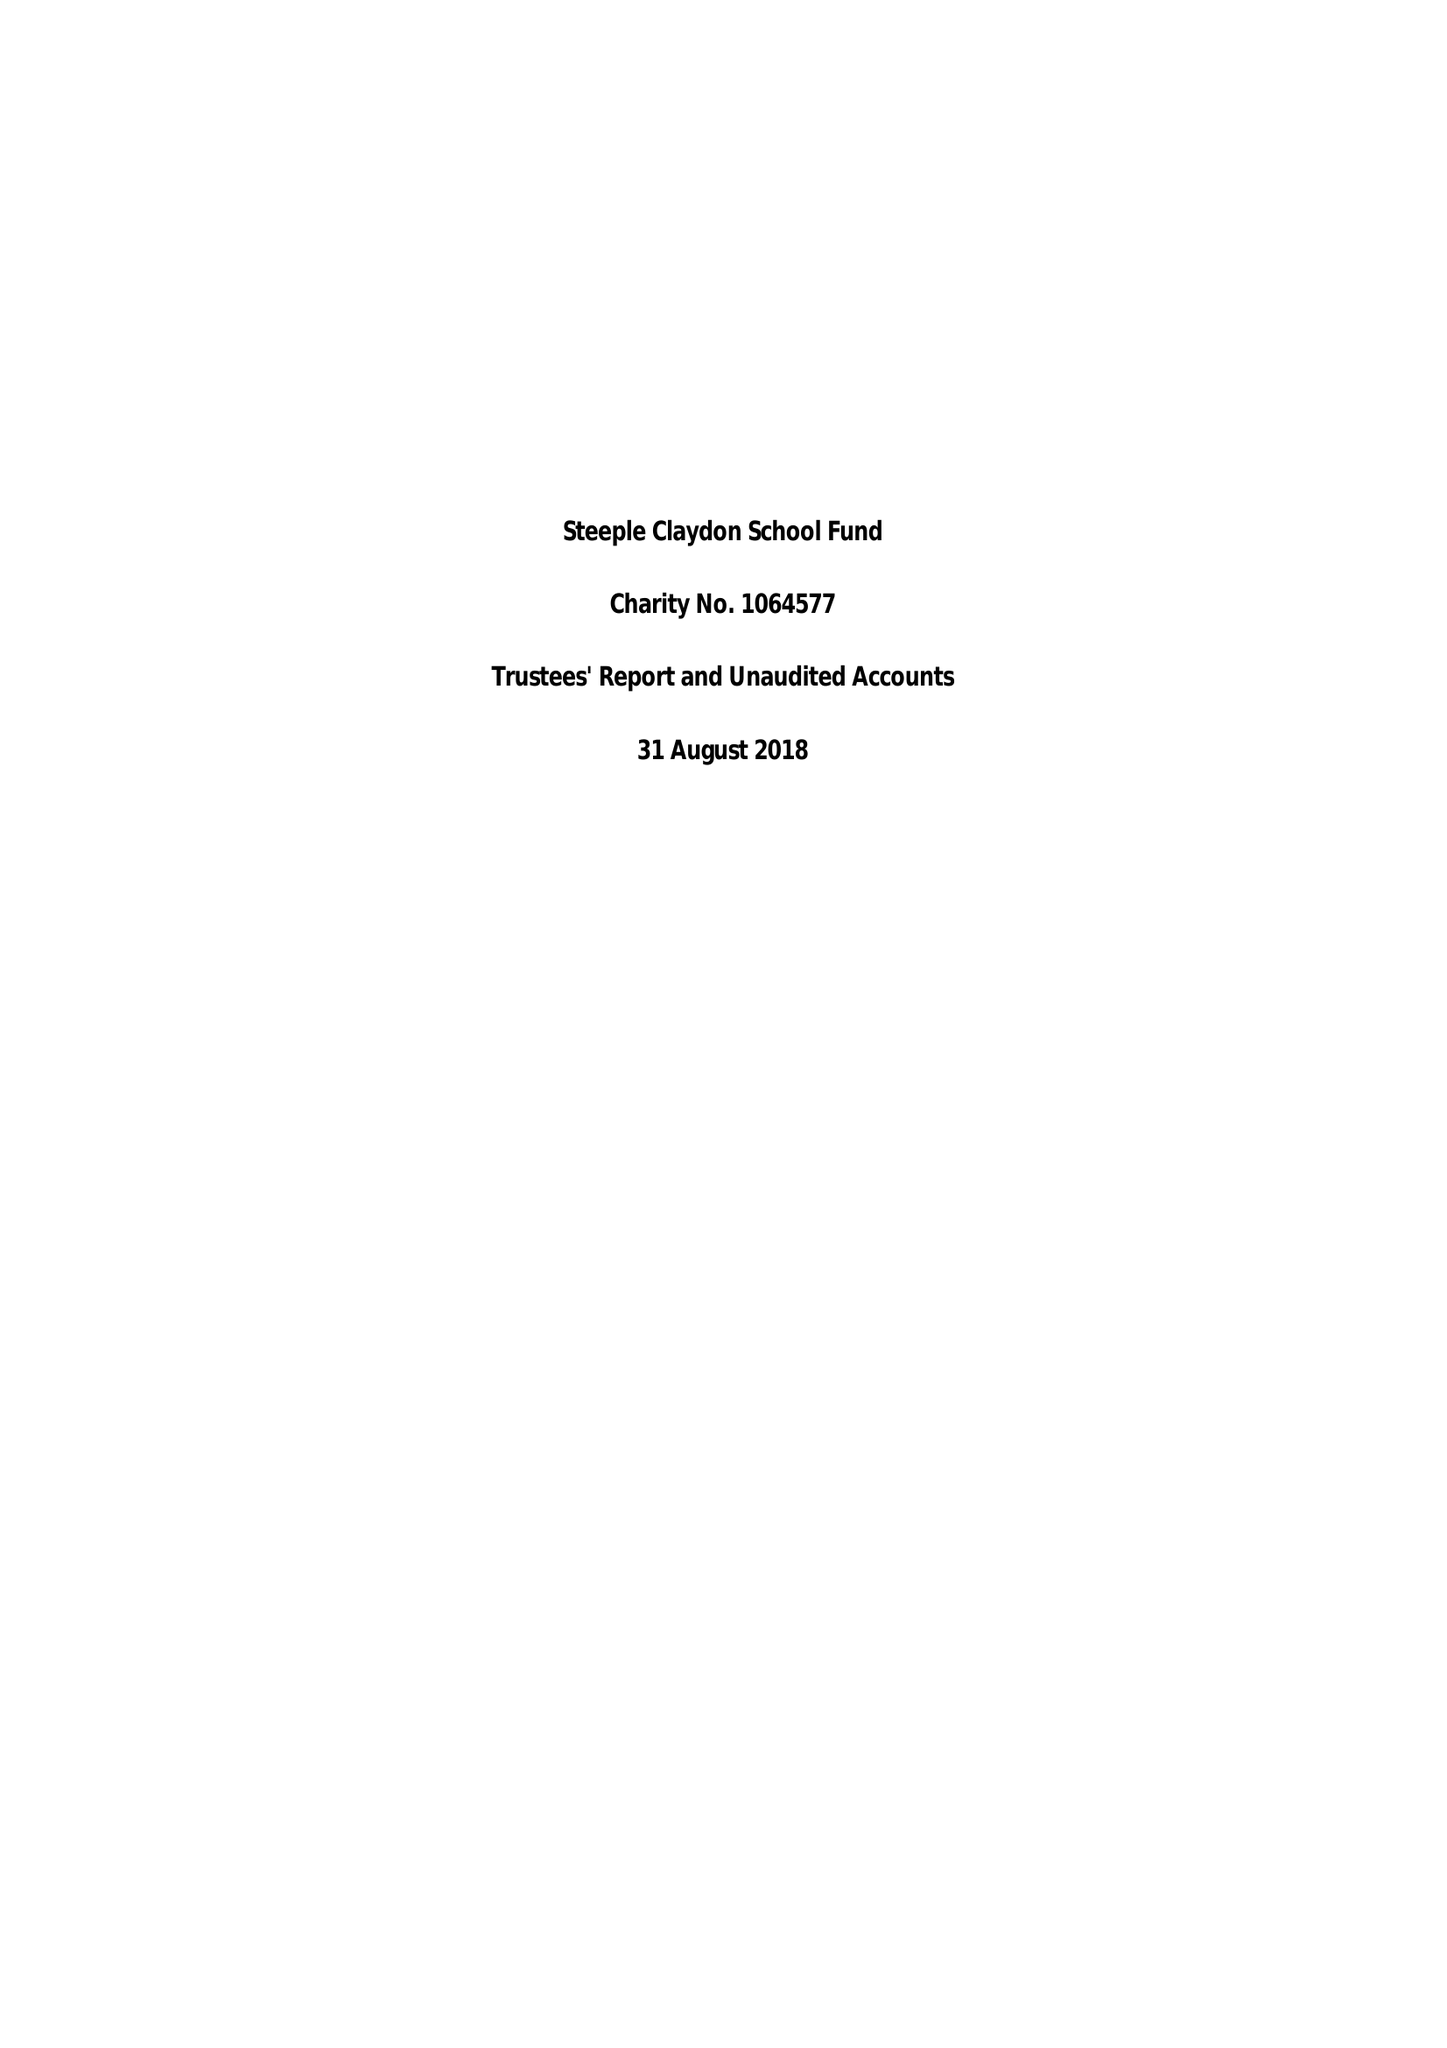What is the value for the spending_annually_in_british_pounds?
Answer the question using a single word or phrase. 58387.00 